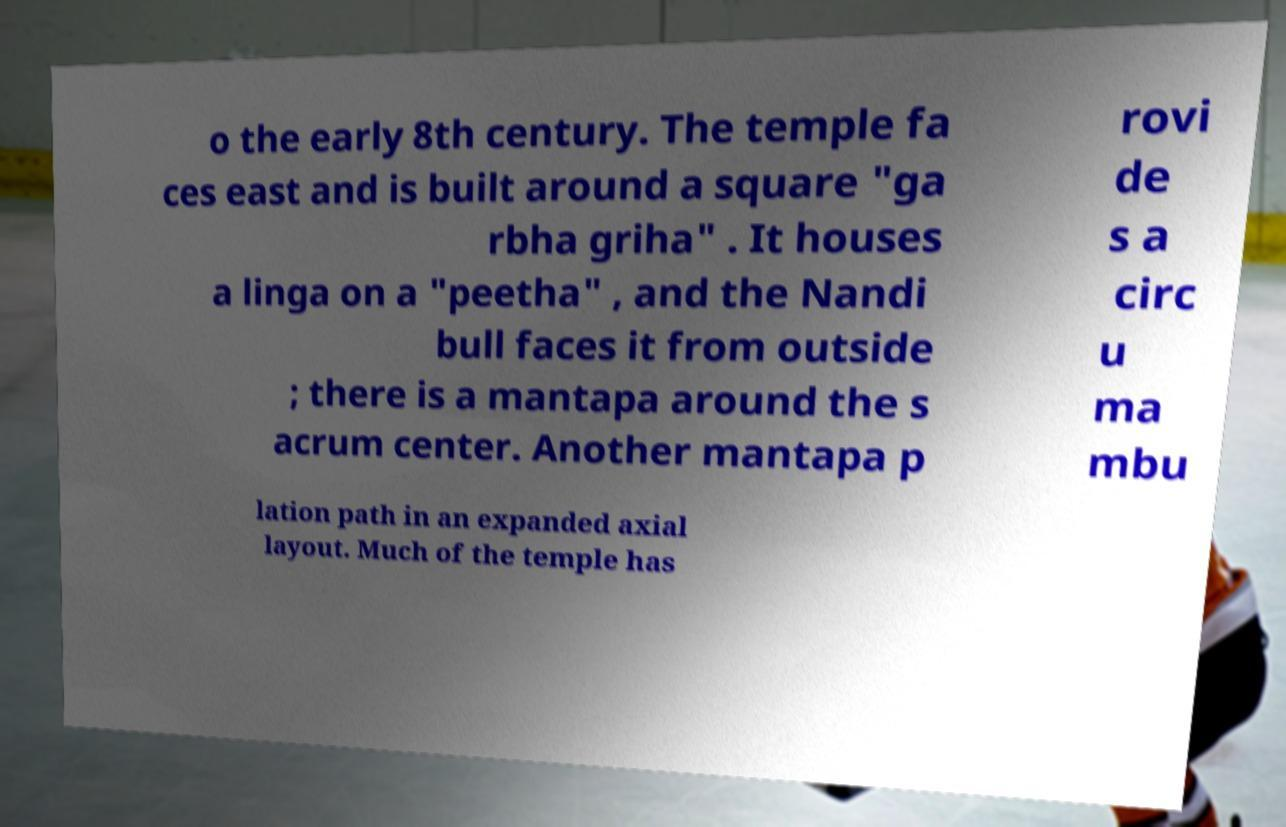There's text embedded in this image that I need extracted. Can you transcribe it verbatim? o the early 8th century. The temple fa ces east and is built around a square "ga rbha griha" . It houses a linga on a "peetha" , and the Nandi bull faces it from outside ; there is a mantapa around the s acrum center. Another mantapa p rovi de s a circ u ma mbu lation path in an expanded axial layout. Much of the temple has 